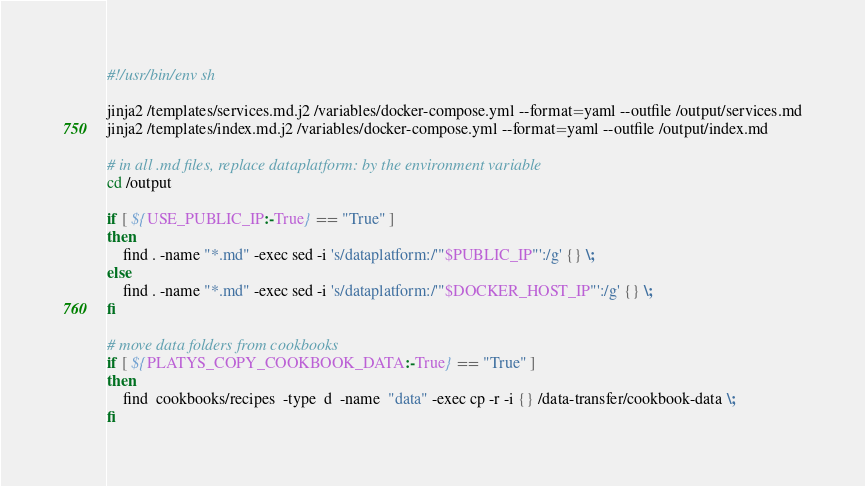<code> <loc_0><loc_0><loc_500><loc_500><_Bash_>#!/usr/bin/env sh

jinja2 /templates/services.md.j2 /variables/docker-compose.yml --format=yaml --outfile /output/services.md
jinja2 /templates/index.md.j2 /variables/docker-compose.yml --format=yaml --outfile /output/index.md

# in all .md files, replace dataplatform: by the environment variable
cd /output

if [ ${USE_PUBLIC_IP:-True} == "True" ]
then
	find . -name "*.md" -exec sed -i 's/dataplatform:/'"$PUBLIC_IP"':/g' {} \;
else
	find . -name "*.md" -exec sed -i 's/dataplatform:/'"$DOCKER_HOST_IP"':/g' {} \;
fi	

# move data folders from cookbooks
if [ ${PLATYS_COPY_COOKBOOK_DATA:-True} == "True" ]
then
	find  cookbooks/recipes  -type  d  -name  "data" -exec cp -r -i {} /data-transfer/cookbook-data \;
fi	</code> 